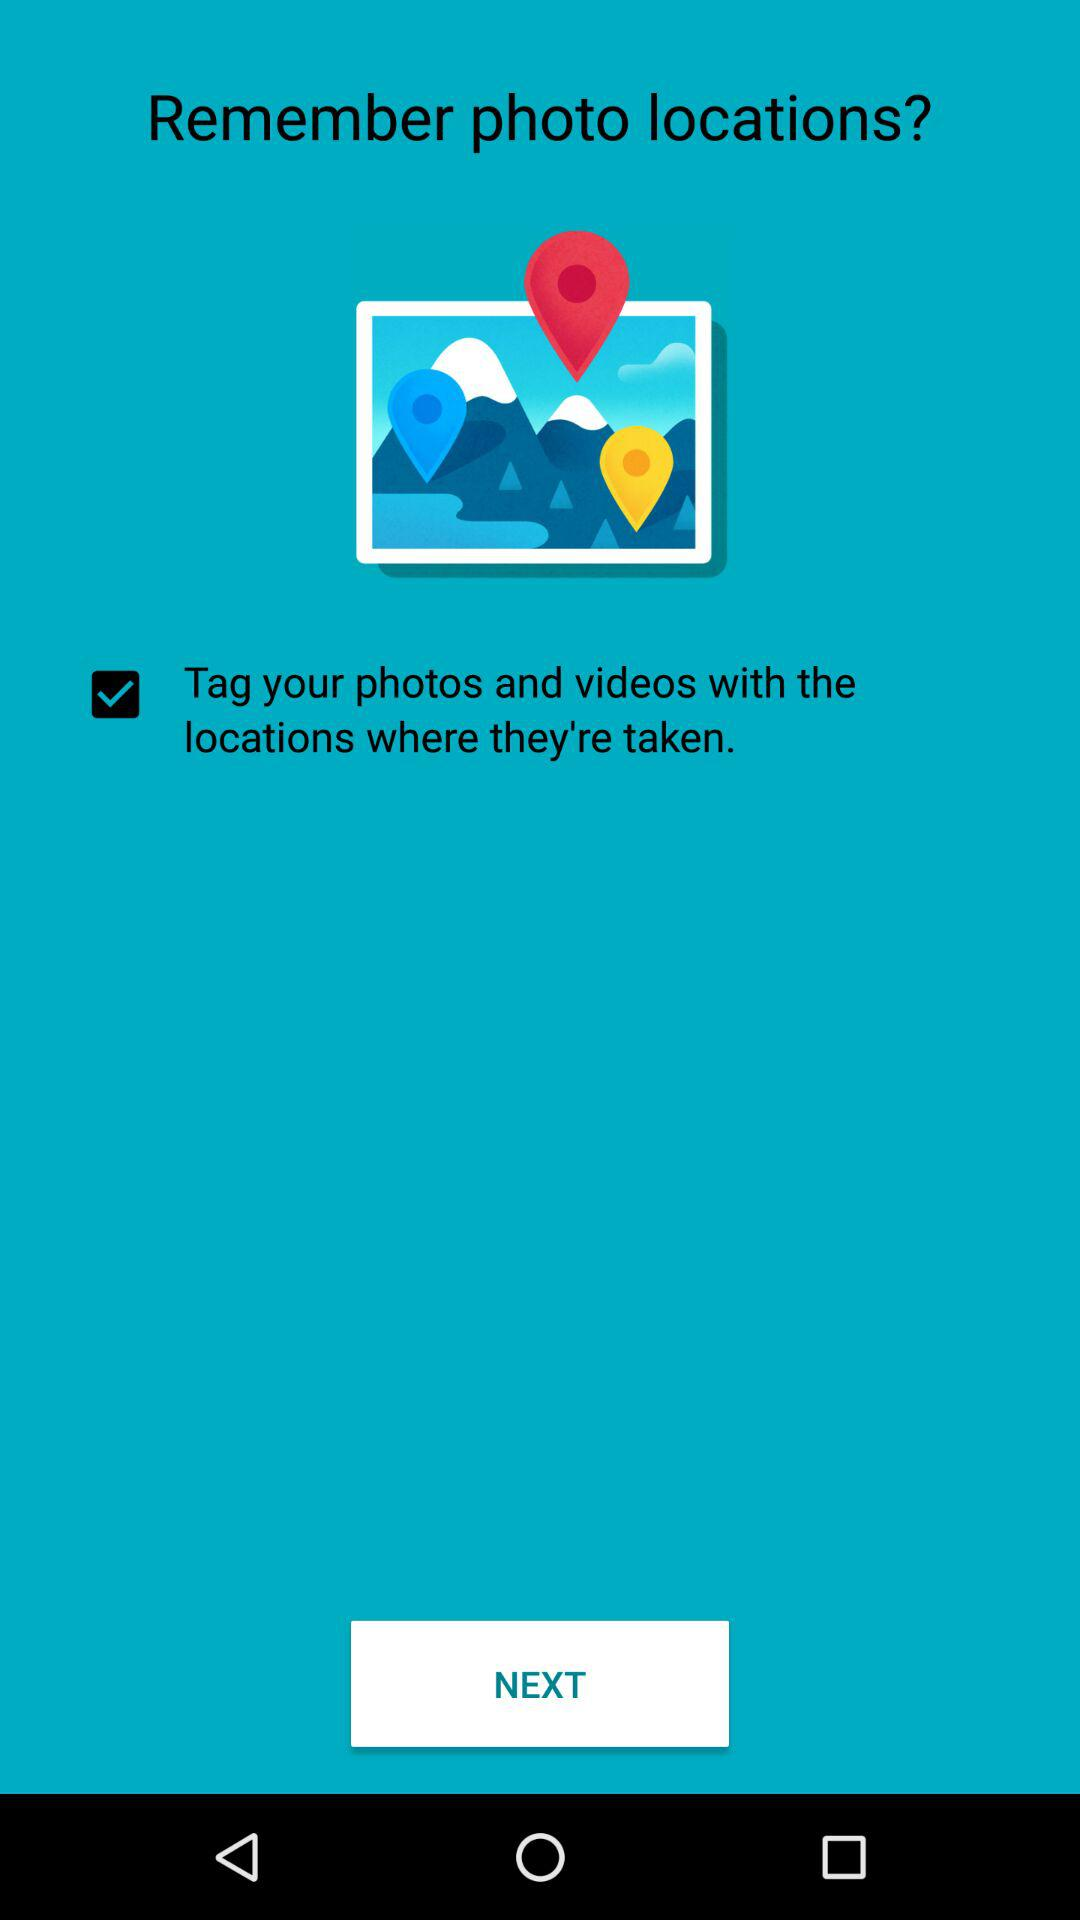What is the status of "Tag your photos and videos with the locations where they're taken."? The status is "on". 